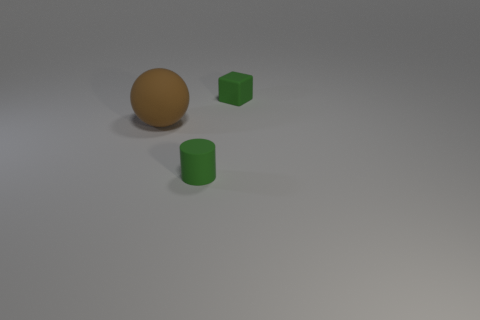Add 1 small red matte blocks. How many objects exist? 4 Subtract all spheres. How many objects are left? 2 Subtract 0 cyan balls. How many objects are left? 3 Subtract all matte balls. Subtract all brown spheres. How many objects are left? 1 Add 2 large brown rubber objects. How many large brown rubber objects are left? 3 Add 2 small objects. How many small objects exist? 4 